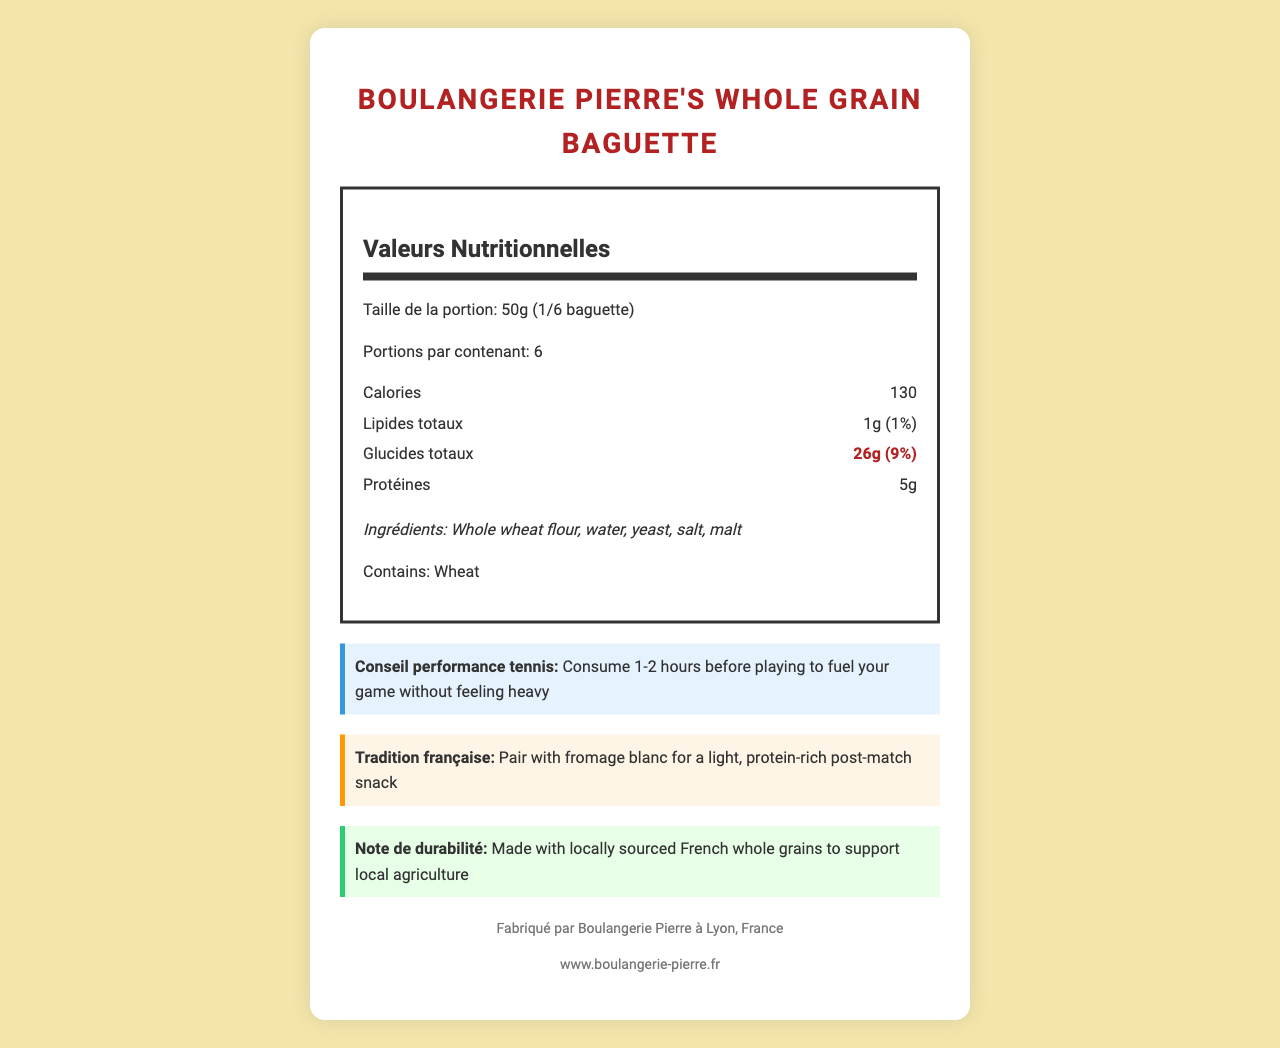who is the manufacturer of Boulangerie Pierre's Whole Grain Baguette? According to the manufacturer information section, the product is made by Boulangerie Pierre.
Answer: Boulangerie Pierre what is the serving size of the baguette? The serving size is mentioned as 50g (1/6 baguette) right at the beginning of the nutrition label.
Answer: 50g (1/6 baguette) how much total carbohydrate is in one serving? The total carbohydrate content per serving is specified under the "Glucides totaux" section as 26g.
Answer: 26g what is the percent daily value of sodium per serving? The percent daily value for sodium per serving is listed as 12% in the nutrition information.
Answer: 12% how many calories are in one serving of this baguette? The number of calories per serving is shown to be 130 in the nutrition label.
Answer: 130 what tip does the document provide for tennis players? The tennis performance tip given is to consume 1-2 hours before playing to fuel your game without feeling heavy.
Answer: Consume 1-2 hours before playing to fuel your game without feeling heavy what are the main ingredients of this baguette? A. White flour, water, yeast B. Whole wheat flour, water, yeast C. Whole grain flour, water, malt D. Whole wheat flour, yeast, salt The ingredients listed under the ingredients section are Whole wheat flour, water, yeast, salt, and malt.
Answer: B. Whole wheat flour, water, yeast how much dietary fiber does one serving contain? The nutritional information mentions that each serving contains 2g of dietary fiber.
Answer: 2g what is the purpose of the carbohydrates in the baguette for tennis players? A. To help gain weight B. For muscle repair C. For sustained energy D. None of the above The note in the nutritional highlights specifies that the carbohydrates are essential for providing sustained energy during tennis matches.
Answer: C. For sustained energy is there any trans fat in the baguette? The trans fat content is specified as 0g in the nutrition information.
Answer: No describe the overall document The document is essentially a nutrition facts label that emphasizes the carbohydrate content of the whole grain baguette which is beneficial for tennis players. It includes both basic nutrition information and additional sections like performance tips, French traditions, and sustainability notes.
Answer: This document provides detailed nutritional information about Boulangerie Pierre's Whole Grain Baguette, including serving size, calories, fat, carbohydrates, protein, and micronutrients. It also includes performance tips for tennis players, French tradition suggestions, and sustainability notes, along with the manufacturer's information. where can I buy this baguette in Montpellier? The document does not provide any specific retail locations or availability details for purchasing the baguette in Montpellier or any other place.
Answer: Not enough information 